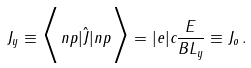Convert formula to latex. <formula><loc_0><loc_0><loc_500><loc_500>J _ { y } \equiv \Big < n p | \hat { J } | n p \Big > = | e | c \frac { E } { B L _ { y } } \equiv J _ { o } \, .</formula> 